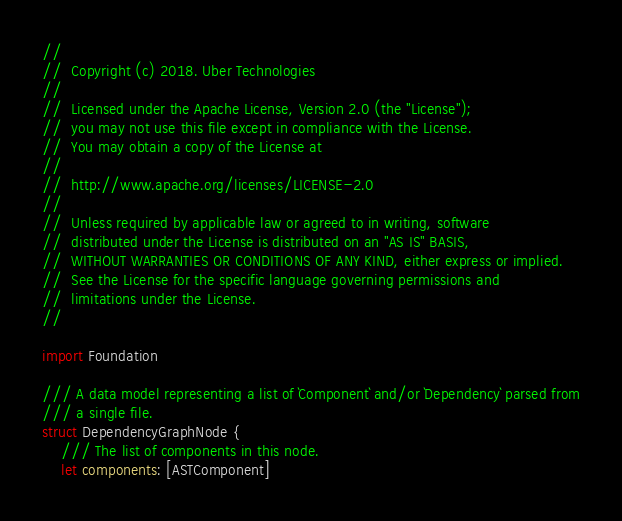Convert code to text. <code><loc_0><loc_0><loc_500><loc_500><_Swift_>//
//  Copyright (c) 2018. Uber Technologies
//
//  Licensed under the Apache License, Version 2.0 (the "License");
//  you may not use this file except in compliance with the License.
//  You may obtain a copy of the License at
//
//  http://www.apache.org/licenses/LICENSE-2.0
//
//  Unless required by applicable law or agreed to in writing, software
//  distributed under the License is distributed on an "AS IS" BASIS,
//  WITHOUT WARRANTIES OR CONDITIONS OF ANY KIND, either express or implied.
//  See the License for the specific language governing permissions and
//  limitations under the License.
//

import Foundation

/// A data model representing a list of `Component` and/or `Dependency` parsed from
/// a single file.
struct DependencyGraphNode {
    /// The list of components in this node.
    let components: [ASTComponent]</code> 